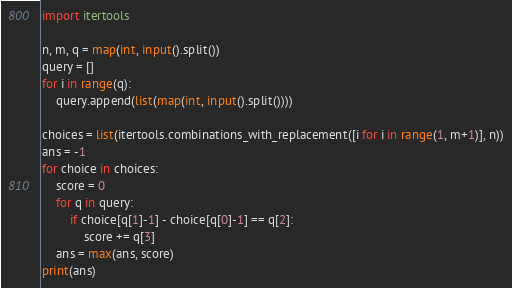Convert code to text. <code><loc_0><loc_0><loc_500><loc_500><_Python_>import itertools

n, m, q = map(int, input().split())
query = []
for i in range(q):
    query.append(list(map(int, input().split())))

choices = list(itertools.combinations_with_replacement([i for i in range(1, m+1)], n))
ans = -1
for choice in choices:
    score = 0
    for q in query:
        if choice[q[1]-1] - choice[q[0]-1] == q[2]:
            score += q[3]
    ans = max(ans, score)
print(ans)</code> 